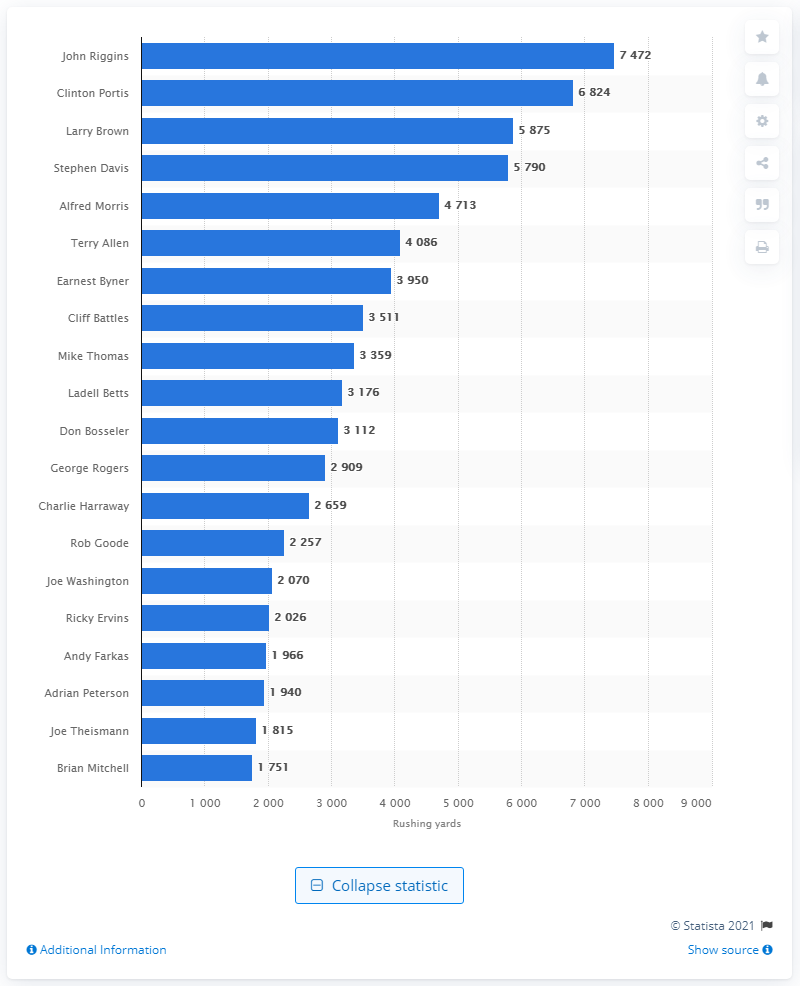Draw attention to some important aspects in this diagram. The career rushing leader of the Washington Football Team is John Riggins. 